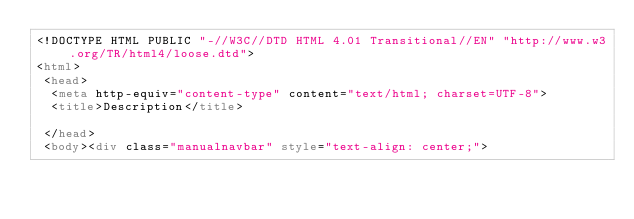<code> <loc_0><loc_0><loc_500><loc_500><_HTML_><!DOCTYPE HTML PUBLIC "-//W3C//DTD HTML 4.01 Transitional//EN" "http://www.w3.org/TR/html4/loose.dtd">
<html>
 <head>
  <meta http-equiv="content-type" content="text/html; charset=UTF-8">
  <title>Description</title>

 </head>
 <body><div class="manualnavbar" style="text-align: center;"></code> 